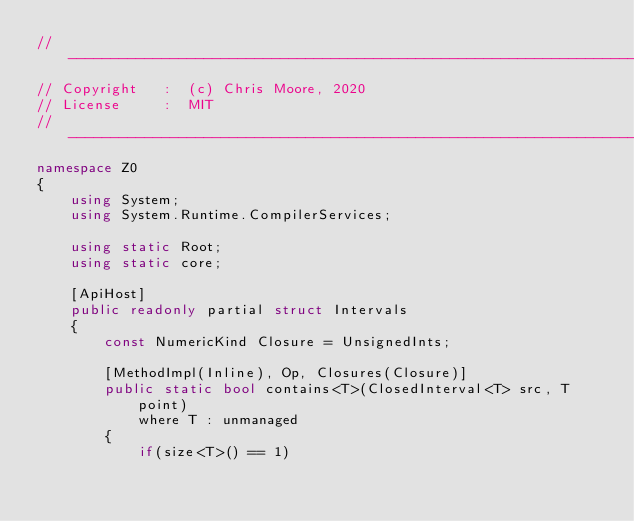Convert code to text. <code><loc_0><loc_0><loc_500><loc_500><_C#_>//-----------------------------------------------------------------------------
// Copyright   :  (c) Chris Moore, 2020
// License     :  MIT
//-----------------------------------------------------------------------------
namespace Z0
{
    using System;
    using System.Runtime.CompilerServices;

    using static Root;
    using static core;

    [ApiHost]
    public readonly partial struct Intervals
    {
        const NumericKind Closure = UnsignedInts;

        [MethodImpl(Inline), Op, Closures(Closure)]
        public static bool contains<T>(ClosedInterval<T> src, T point)
            where T : unmanaged
        {
            if(size<T>() == 1)</code> 